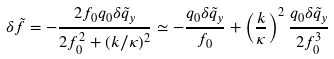<formula> <loc_0><loc_0><loc_500><loc_500>\delta \tilde { f } = - \frac { 2 f _ { 0 } q _ { 0 } \delta \tilde { q } _ { y } } { 2 f _ { 0 } ^ { 2 } + ( k / \kappa ) ^ { 2 } } \simeq - \frac { q _ { 0 } \delta \tilde { q } _ { y } } { f _ { 0 } } + \left ( \frac { k } { \kappa } \right ) ^ { 2 } \frac { q _ { 0 } \delta \tilde { q } _ { y } } { 2 f _ { 0 } ^ { 3 } }</formula> 